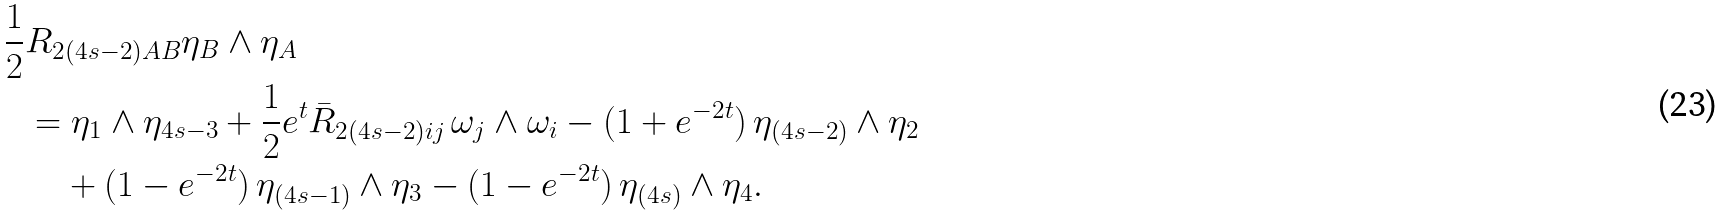<formula> <loc_0><loc_0><loc_500><loc_500>\frac { 1 } { 2 } & R _ { 2 ( 4 s - 2 ) A B } \eta _ { B } \wedge \eta _ { A } \\ & = \eta _ { 1 } \wedge \eta _ { 4 s - 3 } + \frac { 1 } { 2 } e ^ { t } \bar { R } _ { 2 ( 4 s - 2 ) i j } \, \omega _ { j } \wedge \omega _ { i } - ( 1 + e ^ { - 2 t } ) \, \eta _ { ( 4 s - 2 ) } \wedge \eta _ { 2 } \\ & \quad + ( 1 - e ^ { - 2 t } ) \, \eta _ { ( 4 s - 1 ) } \wedge \eta _ { 3 } - ( 1 - e ^ { - 2 t } ) \, \eta _ { ( 4 s ) } \wedge \eta _ { 4 } .</formula> 